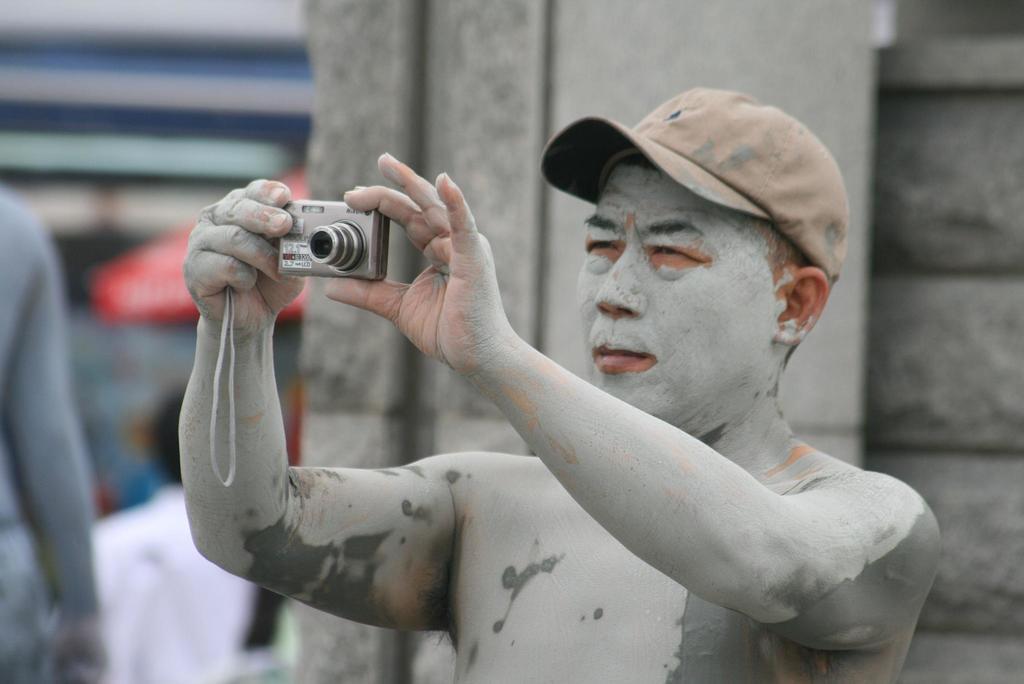In one or two sentences, can you explain what this image depicts? As we can see in the picture that man who is wearing cap and holding a camera in his hand. This man is wearing a cement color powder on his body. Beside this is another man. 